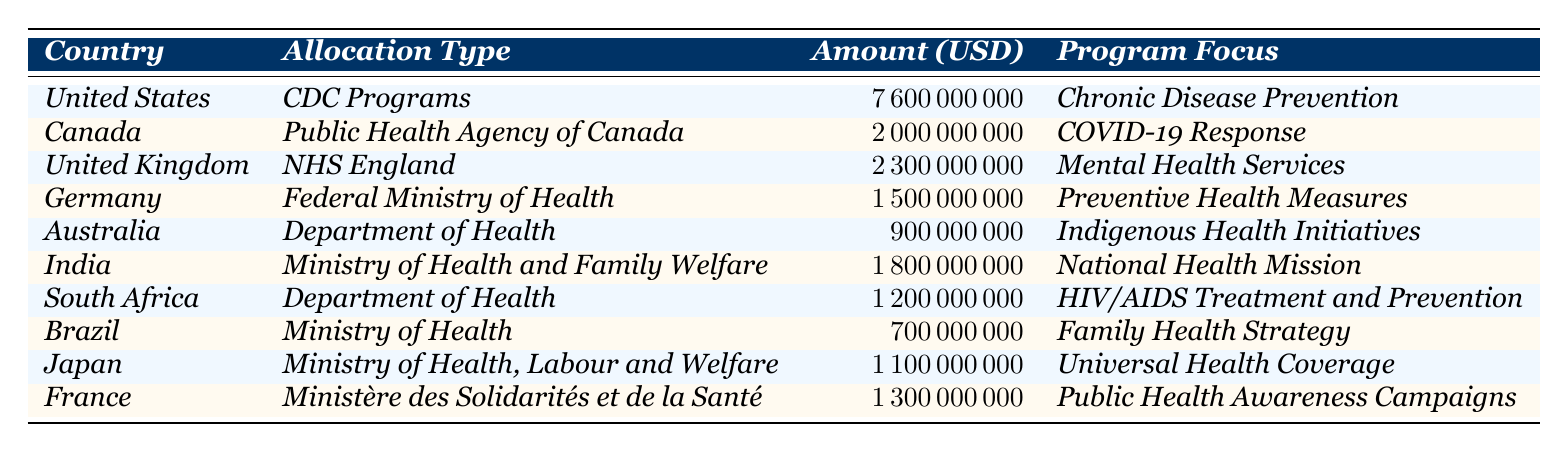What is the total funding allocated by the United States for public health in 2023? According to the table, the amount allocated by the United States for CDC Programs is 7,600,000,000 USD.
Answer: 7,600,000,000 USD Which country has the highest public health funding allocation in 2023? The highest funding allocation listed is for the United States at 7,600,000,000 USD.
Answer: United States How much funding did Canada allocate for COVID-19 Response? The table shows that Canada allocated 2,000,000,000 USD for its Public Health Agency in response to COVID-19.
Answer: 2,000,000,000 USD What is the total amount allocated to mental health services in the UK and Germany combined? The UK allocated 2,300,000,000 USD for mental health services, and Germany allocated 1,500,000,000 USD. The sum is 2,300,000,000 + 1,500,000,000 = 3,800,000,000 USD.
Answer: 3,800,000,000 USD Did any country allocate less than 1 billion USD for public health in 2023? Yes, Brazil allocated 700,000,000 USD, which is less than 1 billion USD.
Answer: Yes What percentage of the total allocations does Australia's funding represent? First, we need to find the total funding by summing all allocations: 7,600,000,000 + 2,000,000,000 + 2,300,000,000 + 1,500,000,000 + 900,000,000 + 1,800,000,000 + 1,200,000,000 + 700,000,000 + 1,100,000,000 + 1,300,000,000 = 20,400,000,000 USD. Australia’s allocation is 900,000,000 USD. The percentage is (900,000,000 / 20,400,000,000) * 100 = 4.41%.
Answer: 4.41% Which country has the smallest allocation and what is the focus of that program? The smallest allocation is for Brazil at 700,000,000 USD, and the program focus is the Family Health Strategy.
Answer: Brazil, Family Health Strategy Are there any countries allocated for both HIV/AIDS treatment and mental health services? No, the countries allocated for HIV/AIDS treatment (South Africa) and mental health services (United Kingdom) are separate; none are allocated for both.
Answer: No If we consider only the amounts allocated for services related to chronic diseases, how does the United States’ contribution compare to the total of all other countries? The only listed allocation for chronic disease prevention is from the United States at 7,600,000,000 USD. Adding all other country allocations except the US gives us 12,800,000,000 USD. The US amount exceeds that of the other countries.
Answer: The US amount exceeds the total of all other countries What is the difference between the funding amounts allocated by India and Japan? India has an allocation of 1,800,000,000 USD and Japan has 1,100,000,000 USD. The difference is 1,800,000,000 - 1,100,000,000 = 700,000,000 USD.
Answer: 700,000,000 USD 